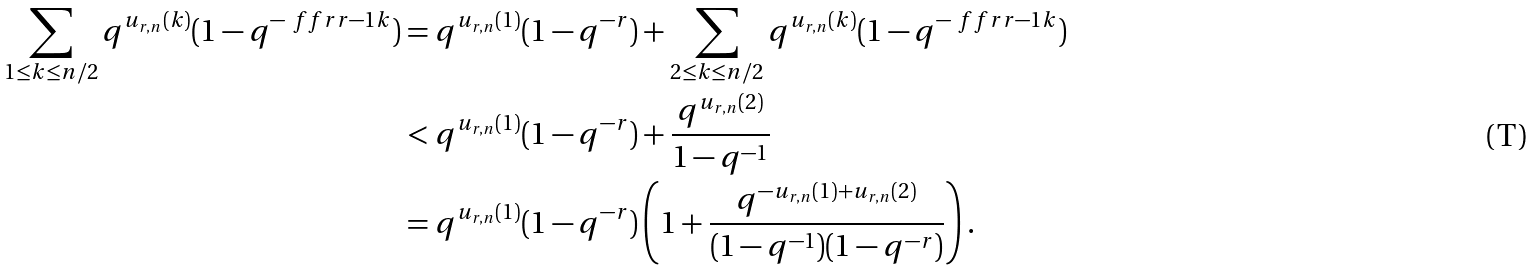<formula> <loc_0><loc_0><loc_500><loc_500>\sum _ { 1 \leq k \leq n / 2 } q ^ { u _ { r , n } ( k ) } ( 1 - q ^ { - \ f f r { r - 1 } { k } } ) & = q ^ { u _ { r , n } ( 1 ) } ( 1 - q ^ { - r } ) + \sum _ { 2 \leq k \leq n / 2 } q ^ { u _ { r , n } ( k ) } ( 1 - q ^ { - \ f f r { r - 1 } { k } } ) \\ & < q ^ { u _ { r , n } ( 1 ) } ( 1 - q ^ { - r } ) + \frac { q ^ { u _ { r , n } ( 2 ) } } { 1 - q ^ { - 1 } } \\ & = q ^ { u _ { r , n } ( 1 ) } ( 1 - q ^ { - r } ) \left ( 1 + \frac { q ^ { - u _ { r , n } ( 1 ) + u _ { r , n } ( 2 ) } } { ( 1 - q ^ { - 1 } ) ( 1 - q ^ { - r } ) } \right ) .</formula> 